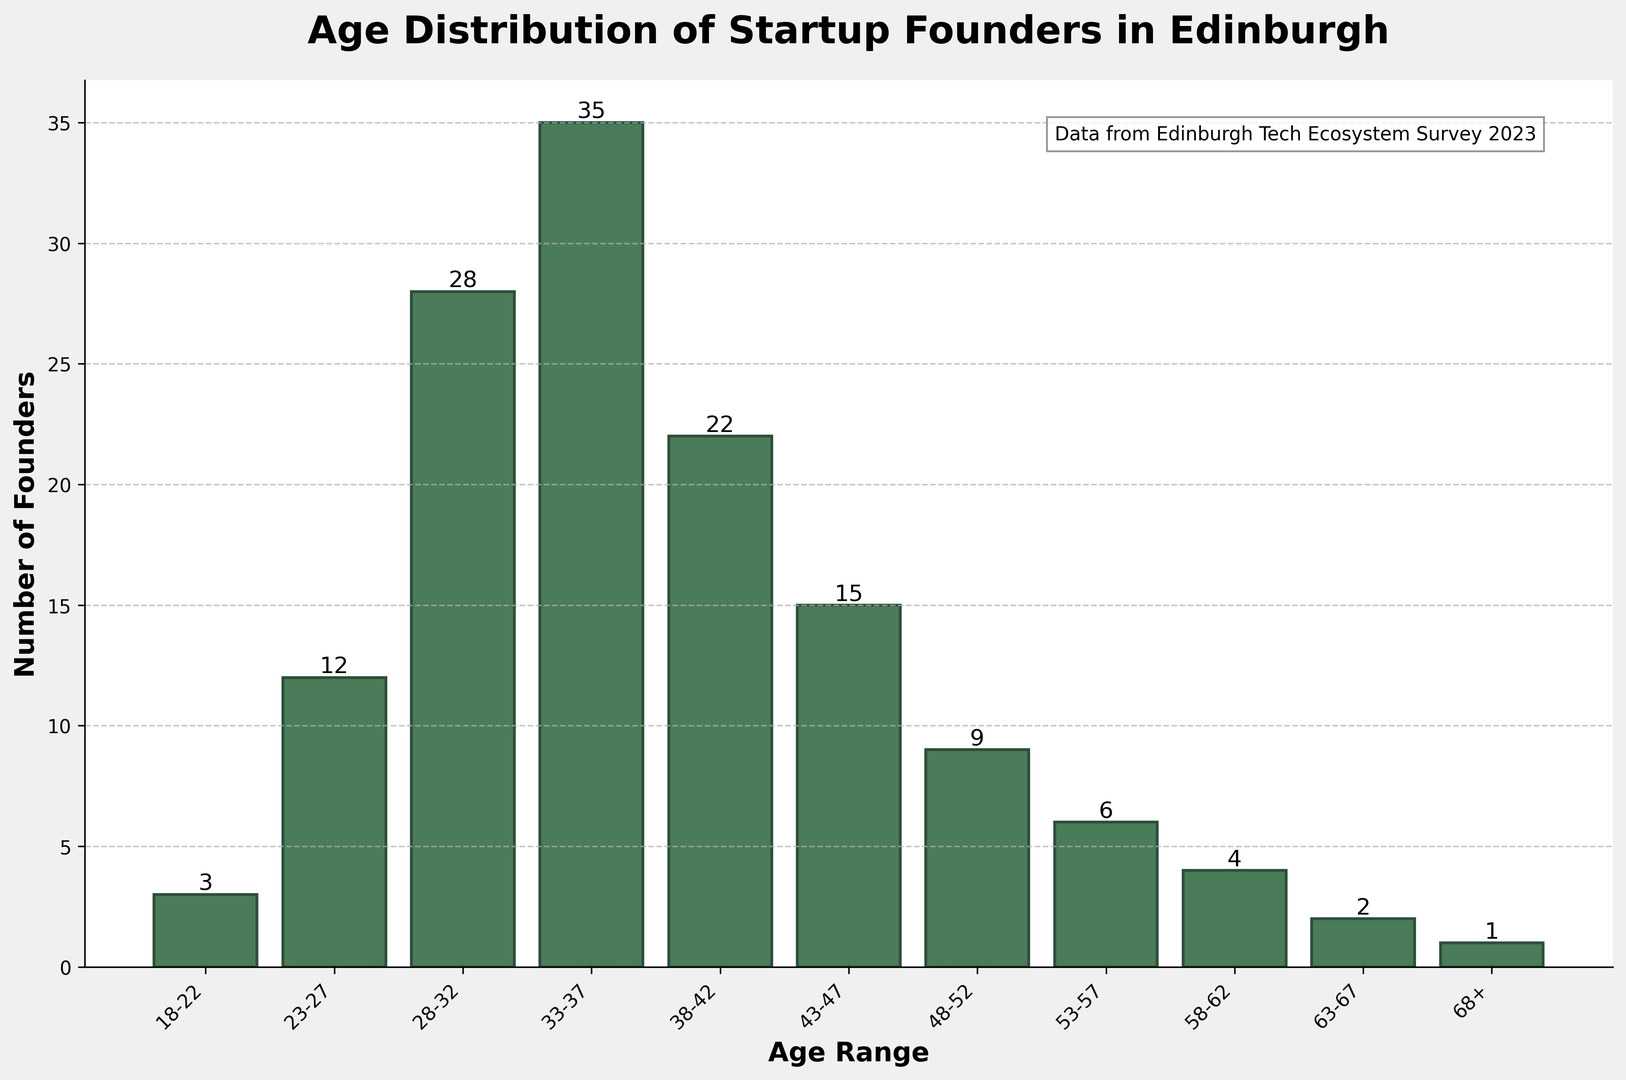What is the age range with the highest number of startup founders? The bar for the age range 33-37 is the tallest among all age ranges. This indicates that the 33-37 age range has the highest frequency of startup founders.
Answer: 33-37 How many startup founders are in the 28-32 and 33-37 age ranges combined? The frequency of startup founders in the 28-32 age range is 28 and in the 33-37 age range is 35. Summing these gives 28 + 35 = 63.
Answer: 63 Which age range has fewer startup founders, 38-42 or 43-47? The bar for the age range 38-42 is taller than the bar for the age range 43-47. The frequencies are 22 for 38-42 and 15 for 43-47, so 43-47 has fewer founders.
Answer: 43-47 What is the total number of startup founders aged 48 and above? The frequencies for age ranges 48-52, 53-57, 58-62, 63-67, and 68+ are 9, 6, 4, 2, and 1 respectively. Summing these values gives 9 + 6 + 4 + 2 + 1 = 22.
Answer: 22 How much taller is the bar for 33-37 compared to the bar for 18-22? The frequency for the 33-37 age range is 35 and for the 18-22 age range is 3. The difference in height is 35 - 3 = 32.
Answer: 32 Is the number of startup founders in the 23-27 age range greater than those in the 43-47 age range? The bar for the 23-27 age range has a frequency of 12 and for the 43-47 age range has a frequency of 15. Thus, the number of founders in 23-27 is not greater than in 43-47.
Answer: No Which age ranges have a frequency of fewer than 5 startup founders? The frequencies of age ranges 18-22, 58-62, 63-67, and 68+ are 3, 4, 2, and 1 respectively. All these frequencies are fewer than 5.
Answer: 18-22, 58-62, 63-67, 68+ What is the median age range of startup founders? Since there are 137 founders in total, the median founder would fall on the 69th and 70th positions. Adding frequencies from the smallest age range up to include the age range that reaches or exceeds 69 and 70 (35 from 33-37 and 28 from 28-32) lands the median within 33-37.
Answer: 33-37 How many more startup founders are there in the 33-37 age range compared to the 23-27 age range? The frequency for the 33-37 age range is 35, and for the 23-27 age range, it is 12. The difference is 35 - 12 = 23.
Answer: 23 